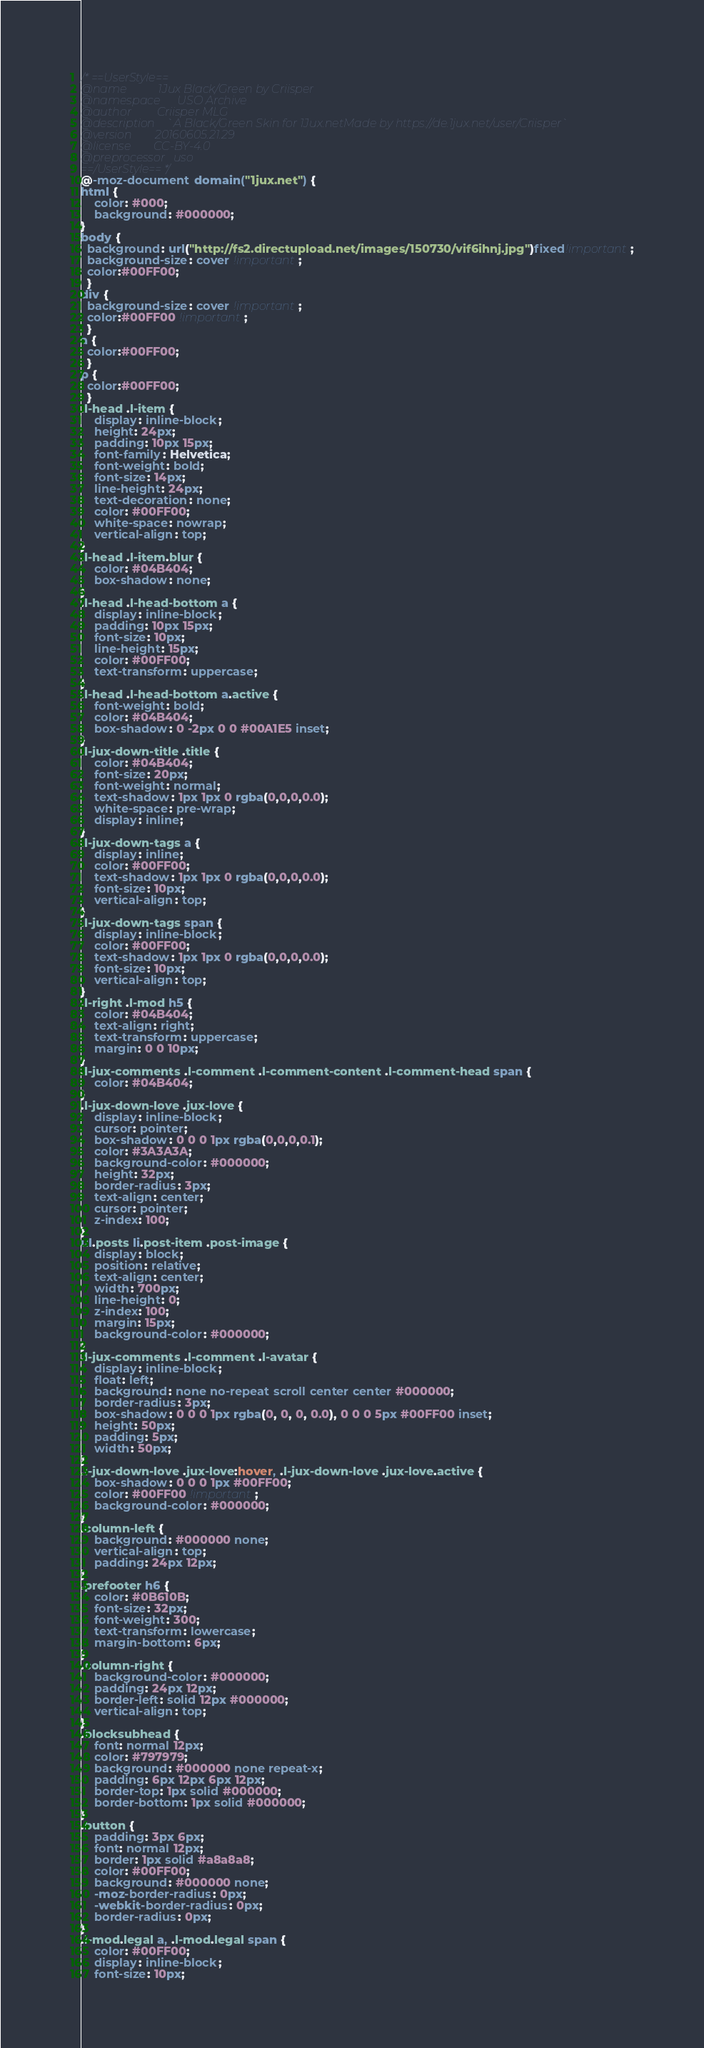<code> <loc_0><loc_0><loc_500><loc_500><_CSS_>/* ==UserStyle==
@name           1Jux Black/Green by Criisper
@namespace      USO Archive
@author         Criisper MLG
@description    `A Black/Green Skin for 1Jux.netMade by https://de.1jux.net/user/Criisper`
@version        20160605.21.29
@license        CC-BY-4.0
@preprocessor   uso
==/UserStyle== */
@-moz-document domain("1jux.net") {
html {
    color: #000;
    background: #000000;
}
body {
  background: url("http://fs2.directupload.net/images/150730/vif6ihnj.jpg")fixed!important;
  background-size: cover !important;
  color:#00FF00;
  }
div {
  background-size: cover !important;
  color:#00FF00 !important;
  }
a {
  color:#00FF00;
  }
p {
  color:#00FF00;
  }
.l-head .l-item {
    display: inline-block;
    height: 24px;
    padding: 10px 15px;
    font-family: Helvetica;
    font-weight: bold;
    font-size: 14px;
    line-height: 24px;
    text-decoration: none;
    color: #00FF00;
    white-space: nowrap;
    vertical-align: top;
}
.l-head .l-item.blur {
    color: #04B404;
    box-shadow: none;
}
.l-head .l-head-bottom a {
    display: inline-block;
    padding: 10px 15px;
    font-size: 10px;
    line-height: 15px;
    color: #00FF00;
    text-transform: uppercase;
}
.l-head .l-head-bottom a.active {
    font-weight: bold;
    color: #04B404;
    box-shadow: 0 -2px 0 0 #00A1E5 inset;
}
.l-jux-down-title .title {
    color: #04B404;
    font-size: 20px;
    font-weight: normal;
    text-shadow: 1px 1px 0 rgba(0,0,0,0.0);
    white-space: pre-wrap;
    display: inline;
}
.l-jux-down-tags a {
    display: inline;
    color: #00FF00;
    text-shadow: 1px 1px 0 rgba(0,0,0,0.0);
    font-size: 10px;
    vertical-align: top;
}
.l-jux-down-tags span {
    display: inline-block;
    color: #00FF00;
    text-shadow: 1px 1px 0 rgba(0,0,0,0.0);
    font-size: 10px;
    vertical-align: top;
}
.l-right .l-mod h5 {
    color: #04B404;
    text-align: right;
    text-transform: uppercase;
    margin: 0 0 10px;
}
.l-jux-comments .l-comment .l-comment-content .l-comment-head span {
    color: #04B404;
}
.l-jux-down-love .jux-love {
    display: inline-block;
    cursor: pointer;
    box-shadow: 0 0 0 1px rgba(0,0,0,0.1);
    color: #3A3A3A;
    background-color: #000000;
    height: 32px;
    border-radius: 3px;
    text-align: center;
    cursor: pointer;
    z-index: 100;
}
ul.posts li.post-item .post-image {
    display: block;
    position: relative;
    text-align: center;
    width: 700px;
    line-height: 0;
    z-index: 100;
    margin: 15px;
    background-color: #000000;
}
.l-jux-comments .l-comment .l-avatar {
    display: inline-block;
    float: left;
    background: none no-repeat scroll center center #000000;
    border-radius: 3px;
    box-shadow: 0 0 0 1px rgba(0, 0, 0, 0.0), 0 0 0 5px #00FF00 inset;
    height: 50px;
    padding: 5px;
    width: 50px;
}
.l-jux-down-love .jux-love:hover, .l-jux-down-love .jux-love.active {
    box-shadow: 0 0 0 1px #00FF00;
    color: #00FF00 !important;
    background-color: #000000;
}
.column-left {
    background: #000000 none;
    vertical-align: top;
    padding: 24px 12px;
}
.prefooter h6 {
    color: #0B610B;
    font-size: 32px;
    font-weight: 300;
    text-transform: lowercase;
    margin-bottom: 6px;
}
.column-right {
    background-color: #000000;
    padding: 24px 12px;
    border-left: solid 12px #000000;
    vertical-align: top;
}
.blocksubhead {
    font: normal 12px;
    color: #797979;
    background: #000000 none repeat-x;
    padding: 6px 12px 6px 12px;
    border-top: 1px solid #000000;
    border-bottom: 1px solid #000000;
}
.button {
    padding: 3px 6px;
    font: normal 12px;
    border: 1px solid #a8a8a8;
    color: #00FF00;
    background: #000000 none;
    -moz-border-radius: 0px;
    -webkit-border-radius: 0px;
    border-radius: 0px;
}
.l-mod.legal a, .l-mod.legal span {
    color: #00FF00;
    display: inline-block;
    font-size: 10px;</code> 